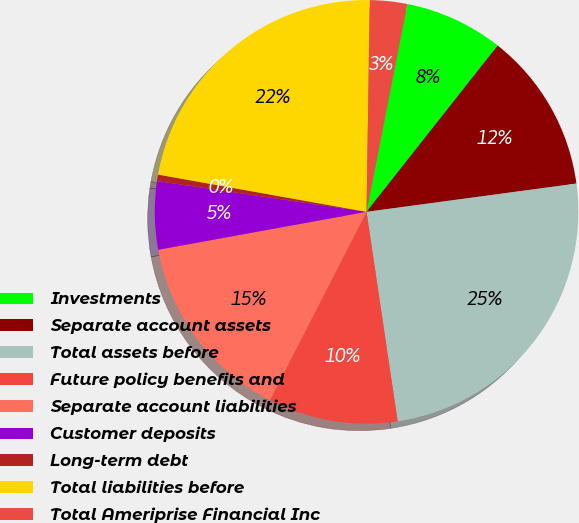<chart> <loc_0><loc_0><loc_500><loc_500><pie_chart><fcel>Investments<fcel>Separate account assets<fcel>Total assets before<fcel>Future policy benefits and<fcel>Separate account liabilities<fcel>Customer deposits<fcel>Long-term debt<fcel>Total liabilities before<fcel>Total Ameriprise Financial Inc<nl><fcel>7.54%<fcel>12.24%<fcel>24.78%<fcel>9.89%<fcel>14.59%<fcel>5.19%<fcel>0.49%<fcel>22.43%<fcel>2.84%<nl></chart> 